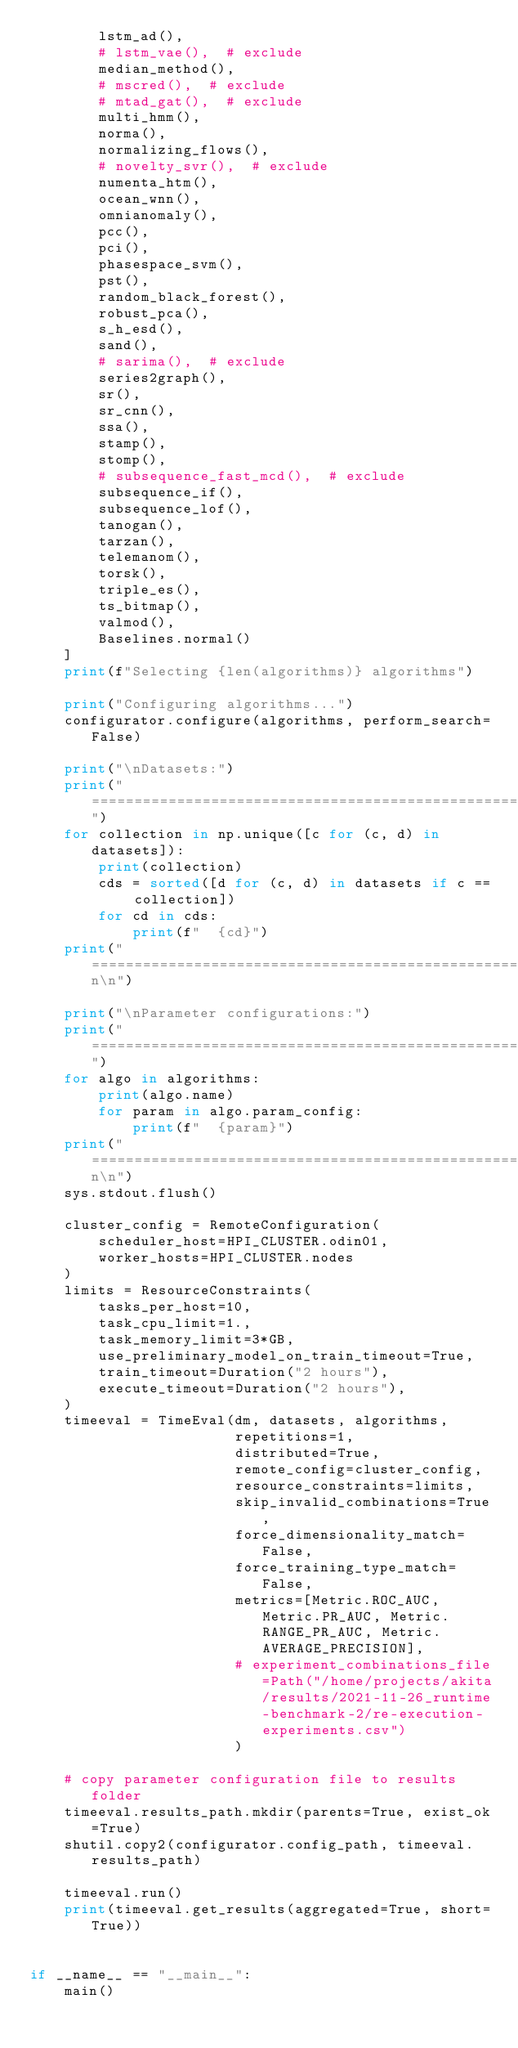<code> <loc_0><loc_0><loc_500><loc_500><_Python_>        lstm_ad(),
        # lstm_vae(),  # exclude
        median_method(),
        # mscred(),  # exclude
        # mtad_gat(),  # exclude
        multi_hmm(),
        norma(),
        normalizing_flows(),
        # novelty_svr(),  # exclude
        numenta_htm(),
        ocean_wnn(),
        omnianomaly(),
        pcc(),
        pci(),
        phasespace_svm(),
        pst(),
        random_black_forest(),
        robust_pca(),
        s_h_esd(),
        sand(),
        # sarima(),  # exclude
        series2graph(),
        sr(),
        sr_cnn(),
        ssa(),
        stamp(),
        stomp(),
        # subsequence_fast_mcd(),  # exclude
        subsequence_if(),
        subsequence_lof(),
        tanogan(),
        tarzan(),
        telemanom(),
        torsk(),
        triple_es(),
        ts_bitmap(),
        valmod(),
        Baselines.normal()
    ]
    print(f"Selecting {len(algorithms)} algorithms")

    print("Configuring algorithms...")
    configurator.configure(algorithms, perform_search=False)

    print("\nDatasets:")
    print("=====================================================================================")
    for collection in np.unique([c for (c, d) in datasets]):
        print(collection)
        cds = sorted([d for (c, d) in datasets if c == collection])
        for cd in cds:
            print(f"  {cd}")
    print("=====================================================================================\n\n")

    print("\nParameter configurations:")
    print("=====================================================================================")
    for algo in algorithms:
        print(algo.name)
        for param in algo.param_config:
            print(f"  {param}")
    print("=====================================================================================\n\n")
    sys.stdout.flush()

    cluster_config = RemoteConfiguration(
        scheduler_host=HPI_CLUSTER.odin01,
        worker_hosts=HPI_CLUSTER.nodes
    )
    limits = ResourceConstraints(
        tasks_per_host=10,
        task_cpu_limit=1.,
        task_memory_limit=3*GB,
        use_preliminary_model_on_train_timeout=True,
        train_timeout=Duration("2 hours"),
        execute_timeout=Duration("2 hours"),
    )
    timeeval = TimeEval(dm, datasets, algorithms,
                        repetitions=1,
                        distributed=True,
                        remote_config=cluster_config,
                        resource_constraints=limits,
                        skip_invalid_combinations=True,
                        force_dimensionality_match=False,
                        force_training_type_match=False,
                        metrics=[Metric.ROC_AUC, Metric.PR_AUC, Metric.RANGE_PR_AUC, Metric.AVERAGE_PRECISION],
                        # experiment_combinations_file=Path("/home/projects/akita/results/2021-11-26_runtime-benchmark-2/re-execution-experiments.csv")
                        )

    # copy parameter configuration file to results folder
    timeeval.results_path.mkdir(parents=True, exist_ok=True)
    shutil.copy2(configurator.config_path, timeeval.results_path)

    timeeval.run()
    print(timeeval.get_results(aggregated=True, short=True))


if __name__ == "__main__":
    main()
</code> 